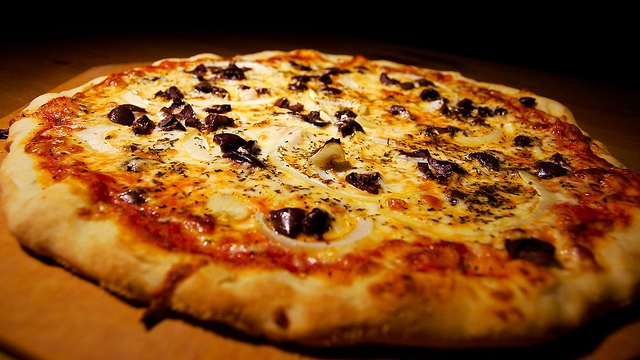Describe the objects in this image and their specific colors. I can see a pizza in black, red, orange, and maroon tones in this image. 